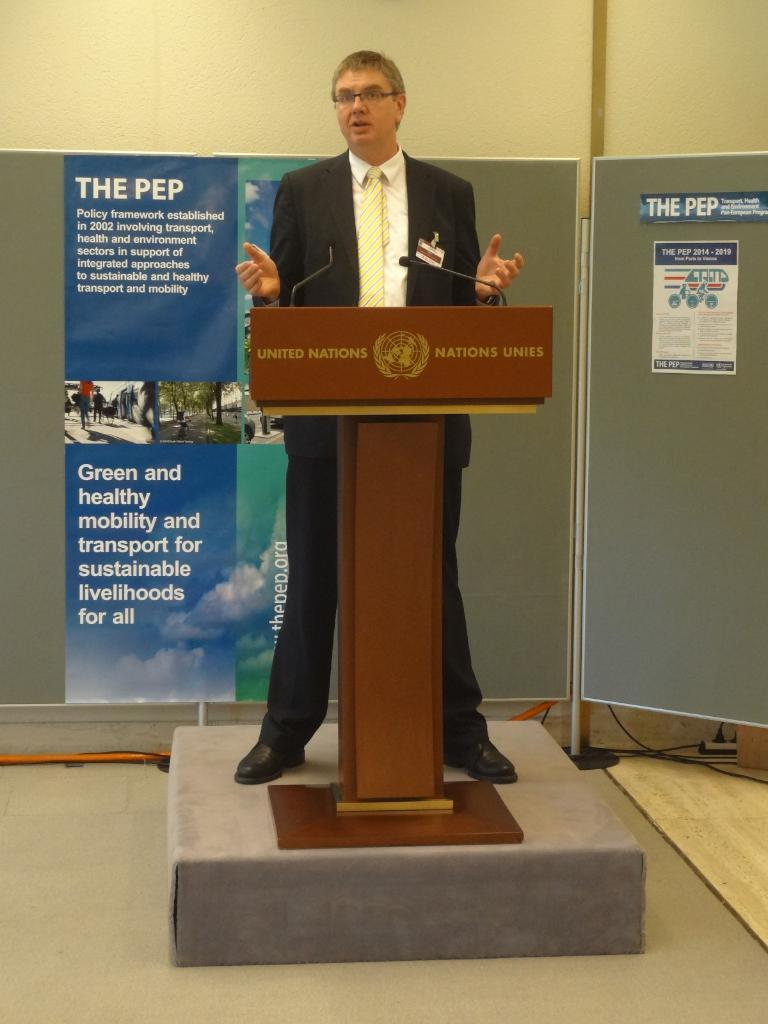Who or what is the main subject of the image? There is a person in the image. Can you describe the person's attire? The person is wearing clothes. What is the person doing in the image? The person is standing in front of a podium. What can be seen in the middle of the image? There is a banner in the middle of the image. What is visible in the background of the image? There is a wall in the background of the image. What type of oatmeal is being served at the event in the image? There is no indication of oatmeal or any event in the image; it simply shows a person standing in front of a podium with a banner and a wall in the background. 